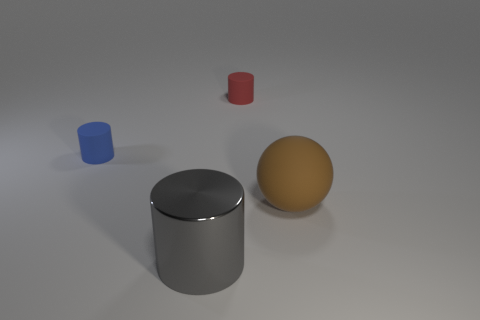Do the blue cylinder and the gray metallic object have the same size?
Your response must be concise. No. What is the material of the large thing on the left side of the small cylinder behind the tiny cylinder to the left of the large metal object?
Keep it short and to the point. Metal. Are there the same number of large spheres behind the red thing and gray cylinders?
Offer a terse response. No. Are there any other things that have the same size as the brown thing?
Keep it short and to the point. Yes. What number of things are tiny blue rubber objects or cyan cubes?
Your response must be concise. 1. What shape is the tiny red object that is made of the same material as the brown sphere?
Provide a succinct answer. Cylinder. There is a red matte cylinder that is behind the small thing that is left of the small red cylinder; how big is it?
Make the answer very short. Small. How many large things are blue cylinders or matte spheres?
Keep it short and to the point. 1. Is the size of the cylinder in front of the big sphere the same as the matte cylinder that is left of the red matte object?
Your response must be concise. No. Is the material of the brown sphere the same as the tiny object to the right of the large gray cylinder?
Keep it short and to the point. Yes. 